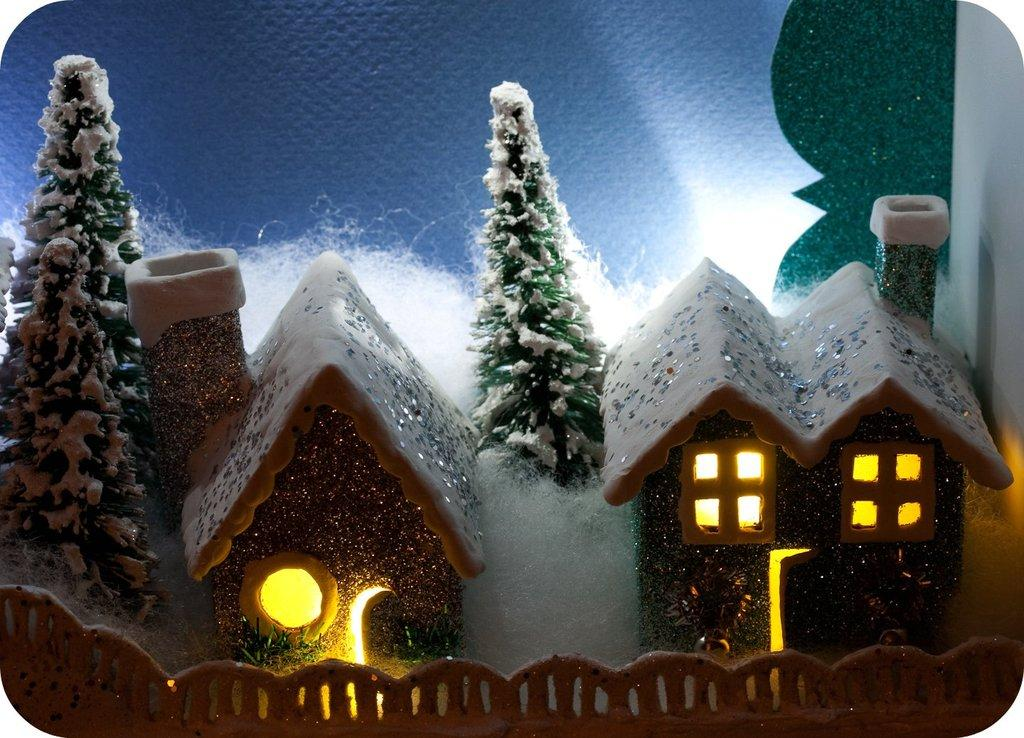What is the main subject of the image? The main subject of the image is a miniature set of two houses. What color light is present in the miniature set? The houses have yellow color light. What type of weather condition is depicted in the miniature set? There is snow in the miniature set. What type of pencil can be seen in the image? There is no pencil present in the image. How does the miniature set expand in the image? The miniature set does not expand in the image; it is a static representation of two houses. 